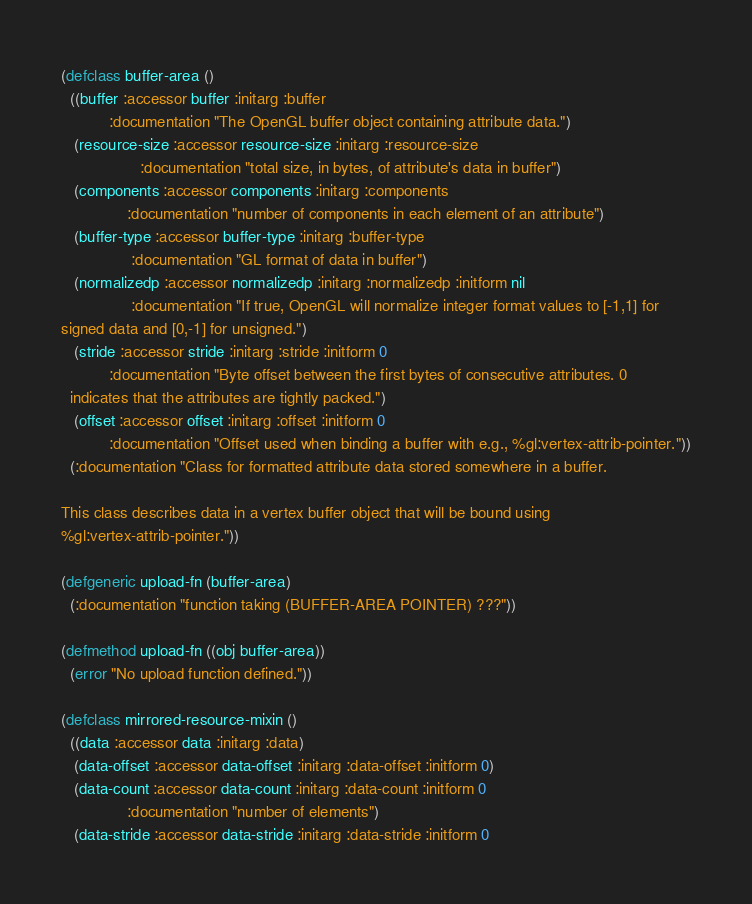<code> <loc_0><loc_0><loc_500><loc_500><_Lisp_>(defclass buffer-area ()
  ((buffer :accessor buffer :initarg :buffer
           :documentation "The OpenGL buffer object containing attribute data.")
   (resource-size :accessor resource-size :initarg :resource-size
                  :documentation "total size, in bytes, of attribute's data in buffer")
   (components :accessor components :initarg :components
               :documentation "number of components in each element of an attribute")
   (buffer-type :accessor buffer-type :initarg :buffer-type
                :documentation "GL format of data in buffer")
   (normalizedp :accessor normalizedp :initarg :normalizedp :initform nil
                :documentation "If true, OpenGL will normalize integer format values to [-1,1] for
signed data and [0,-1] for unsigned.")
   (stride :accessor stride :initarg :stride :initform 0
           :documentation "Byte offset between the first bytes of consecutive attributes. 0
  indicates that the attributes are tightly packed.")
   (offset :accessor offset :initarg :offset :initform 0
           :documentation "Offset used when binding a buffer with e.g., %gl:vertex-attrib-pointer."))
  (:documentation "Class for formatted attribute data stored somewhere in a buffer.

This class describes data in a vertex buffer object that will be bound using
%gl:vertex-attrib-pointer."))

(defgeneric upload-fn (buffer-area)
  (:documentation "function taking (BUFFER-AREA POINTER) ???"))

(defmethod upload-fn ((obj buffer-area))
  (error "No upload function defined."))

(defclass mirrored-resource-mixin ()
  ((data :accessor data :initarg :data)
   (data-offset :accessor data-offset :initarg :data-offset :initform 0)
   (data-count :accessor data-count :initarg :data-count :initform 0
               :documentation "number of elements")
   (data-stride :accessor data-stride :initarg :data-stride :initform 0</code> 